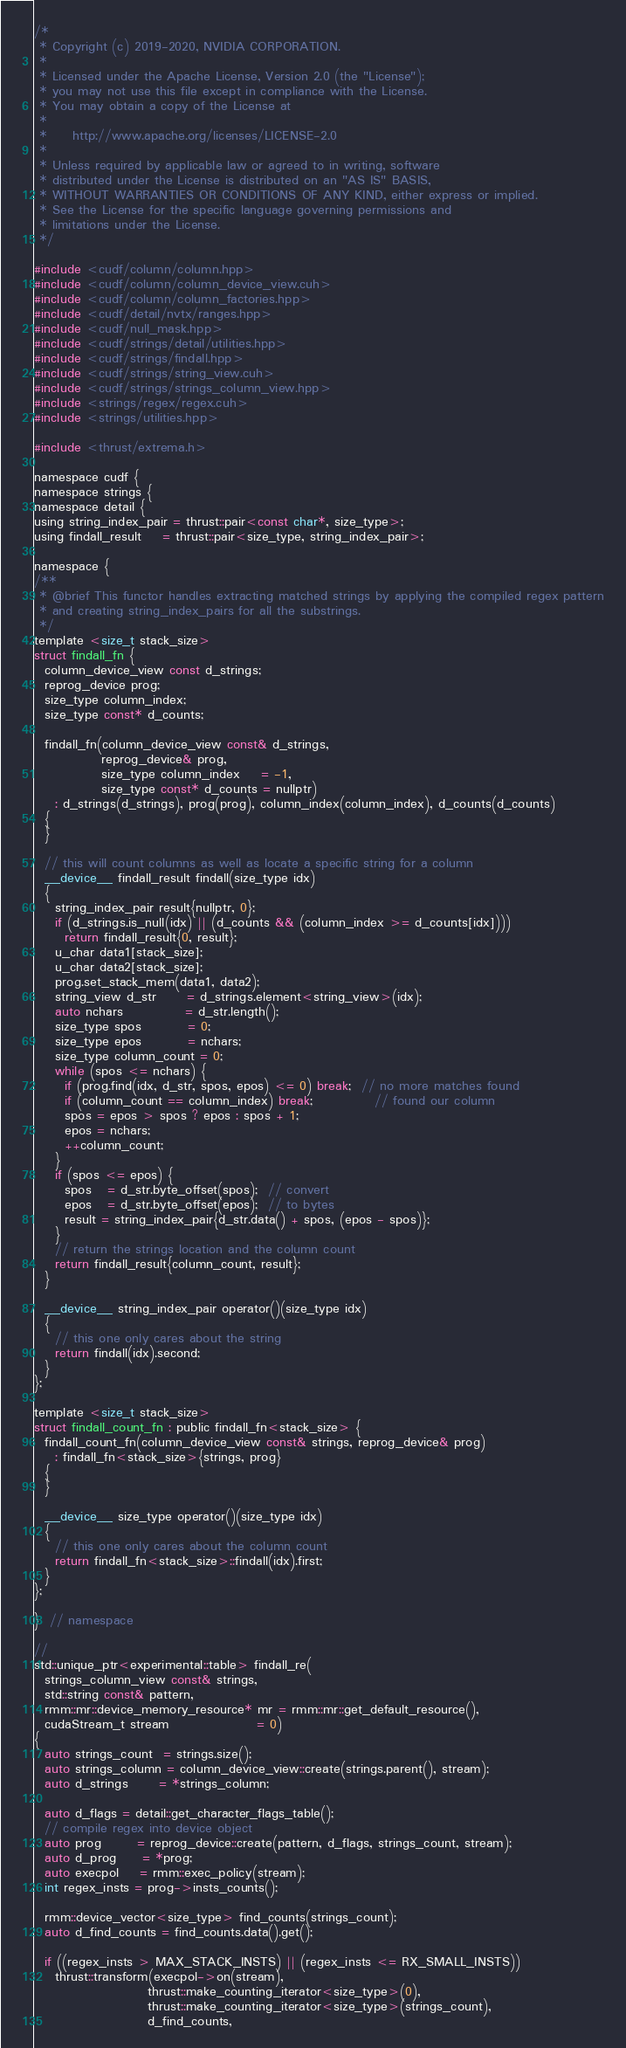<code> <loc_0><loc_0><loc_500><loc_500><_Cuda_>/*
 * Copyright (c) 2019-2020, NVIDIA CORPORATION.
 *
 * Licensed under the Apache License, Version 2.0 (the "License");
 * you may not use this file except in compliance with the License.
 * You may obtain a copy of the License at
 *
 *     http://www.apache.org/licenses/LICENSE-2.0
 *
 * Unless required by applicable law or agreed to in writing, software
 * distributed under the License is distributed on an "AS IS" BASIS,
 * WITHOUT WARRANTIES OR CONDITIONS OF ANY KIND, either express or implied.
 * See the License for the specific language governing permissions and
 * limitations under the License.
 */

#include <cudf/column/column.hpp>
#include <cudf/column/column_device_view.cuh>
#include <cudf/column/column_factories.hpp>
#include <cudf/detail/nvtx/ranges.hpp>
#include <cudf/null_mask.hpp>
#include <cudf/strings/detail/utilities.hpp>
#include <cudf/strings/findall.hpp>
#include <cudf/strings/string_view.cuh>
#include <cudf/strings/strings_column_view.hpp>
#include <strings/regex/regex.cuh>
#include <strings/utilities.hpp>

#include <thrust/extrema.h>

namespace cudf {
namespace strings {
namespace detail {
using string_index_pair = thrust::pair<const char*, size_type>;
using findall_result    = thrust::pair<size_type, string_index_pair>;

namespace {
/**
 * @brief This functor handles extracting matched strings by applying the compiled regex pattern
 * and creating string_index_pairs for all the substrings.
 */
template <size_t stack_size>
struct findall_fn {
  column_device_view const d_strings;
  reprog_device prog;
  size_type column_index;
  size_type const* d_counts;

  findall_fn(column_device_view const& d_strings,
             reprog_device& prog,
             size_type column_index    = -1,
             size_type const* d_counts = nullptr)
    : d_strings(d_strings), prog(prog), column_index(column_index), d_counts(d_counts)
  {
  }

  // this will count columns as well as locate a specific string for a column
  __device__ findall_result findall(size_type idx)
  {
    string_index_pair result{nullptr, 0};
    if (d_strings.is_null(idx) || (d_counts && (column_index >= d_counts[idx])))
      return findall_result{0, result};
    u_char data1[stack_size];
    u_char data2[stack_size];
    prog.set_stack_mem(data1, data2);
    string_view d_str      = d_strings.element<string_view>(idx);
    auto nchars            = d_str.length();
    size_type spos         = 0;
    size_type epos         = nchars;
    size_type column_count = 0;
    while (spos <= nchars) {
      if (prog.find(idx, d_str, spos, epos) <= 0) break;  // no more matches found
      if (column_count == column_index) break;            // found our column
      spos = epos > spos ? epos : spos + 1;
      epos = nchars;
      ++column_count;
    }
    if (spos <= epos) {
      spos   = d_str.byte_offset(spos);  // convert
      epos   = d_str.byte_offset(epos);  // to bytes
      result = string_index_pair{d_str.data() + spos, (epos - spos)};
    }
    // return the strings location and the column count
    return findall_result{column_count, result};
  }

  __device__ string_index_pair operator()(size_type idx)
  {
    // this one only cares about the string
    return findall(idx).second;
  }
};

template <size_t stack_size>
struct findall_count_fn : public findall_fn<stack_size> {
  findall_count_fn(column_device_view const& strings, reprog_device& prog)
    : findall_fn<stack_size>{strings, prog}
  {
  }

  __device__ size_type operator()(size_type idx)
  {
    // this one only cares about the column count
    return findall_fn<stack_size>::findall(idx).first;
  }
};

}  // namespace

//
std::unique_ptr<experimental::table> findall_re(
  strings_column_view const& strings,
  std::string const& pattern,
  rmm::mr::device_memory_resource* mr = rmm::mr::get_default_resource(),
  cudaStream_t stream                 = 0)
{
  auto strings_count  = strings.size();
  auto strings_column = column_device_view::create(strings.parent(), stream);
  auto d_strings      = *strings_column;

  auto d_flags = detail::get_character_flags_table();
  // compile regex into device object
  auto prog       = reprog_device::create(pattern, d_flags, strings_count, stream);
  auto d_prog     = *prog;
  auto execpol    = rmm::exec_policy(stream);
  int regex_insts = prog->insts_counts();

  rmm::device_vector<size_type> find_counts(strings_count);
  auto d_find_counts = find_counts.data().get();

  if ((regex_insts > MAX_STACK_INSTS) || (regex_insts <= RX_SMALL_INSTS))
    thrust::transform(execpol->on(stream),
                      thrust::make_counting_iterator<size_type>(0),
                      thrust::make_counting_iterator<size_type>(strings_count),
                      d_find_counts,</code> 